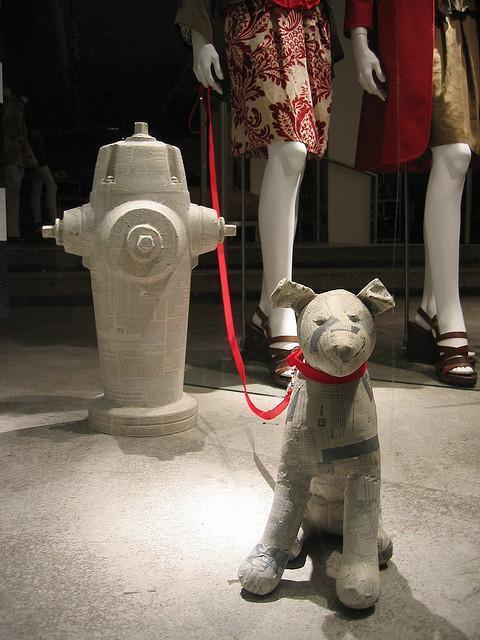How many people are sitting in chairs?
Give a very brief answer. 0. 